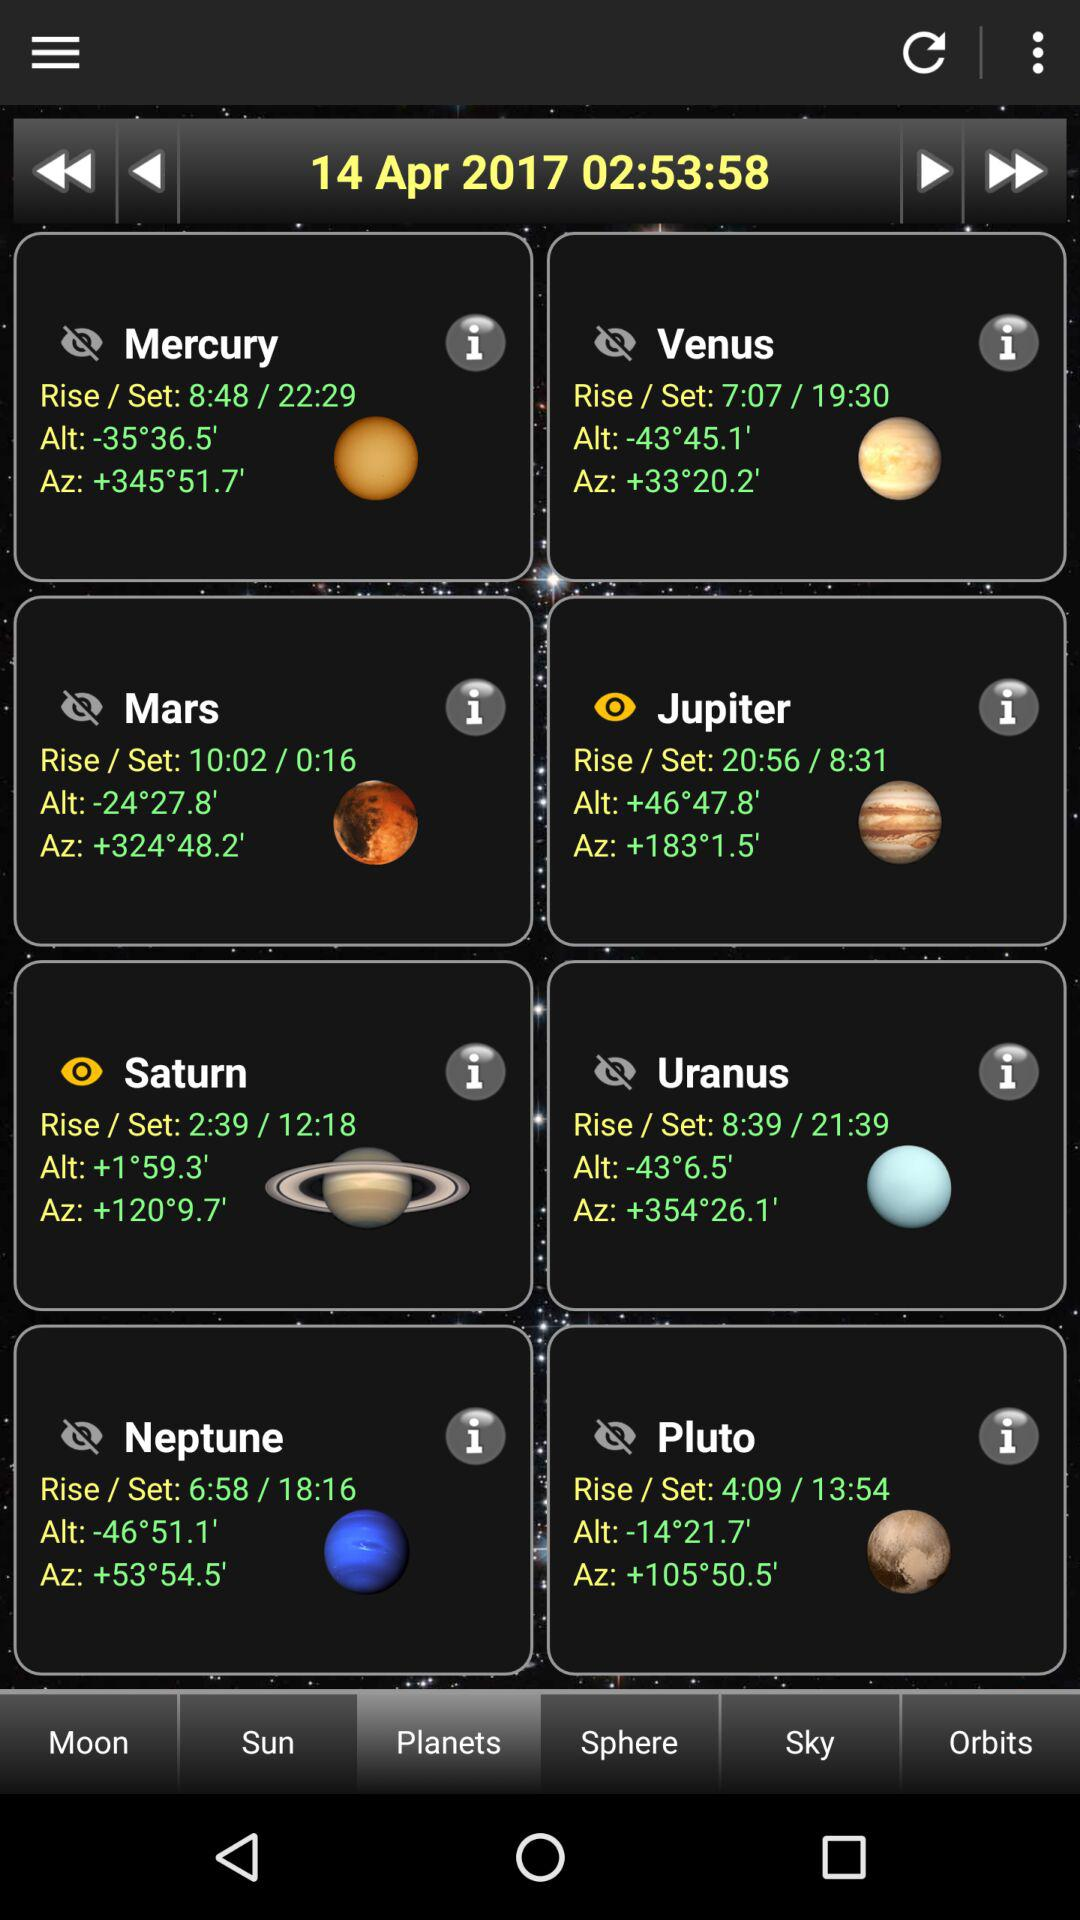At what time does Saturn set? Saturn sets at 12:18. 